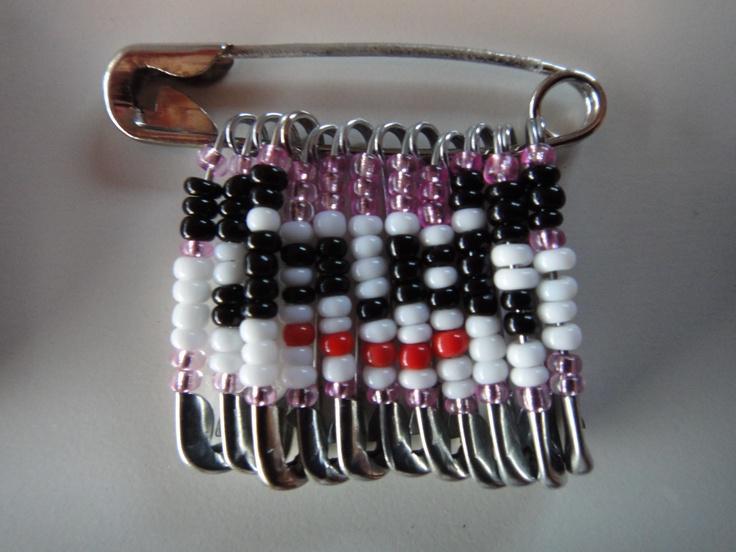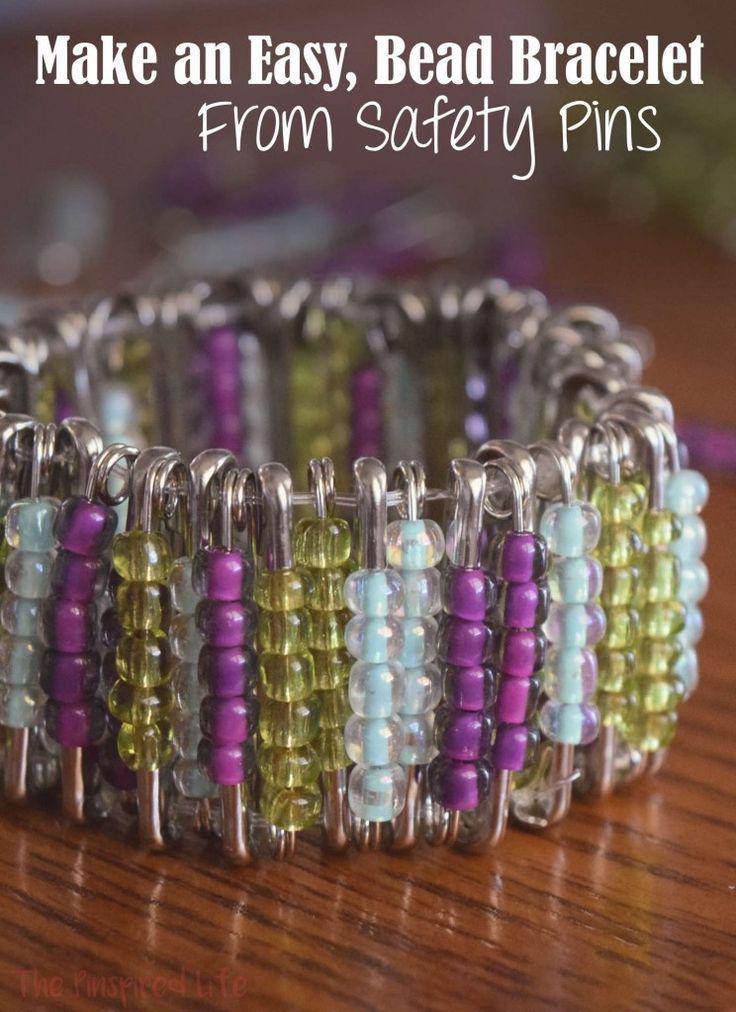The first image is the image on the left, the second image is the image on the right. Considering the images on both sides, is "One image shows a safety pin bracelet displayed on a flat surface, and the other image shows a safety pin strung with colored beads that form an animal image." valid? Answer yes or no. Yes. The first image is the image on the left, the second image is the image on the right. Evaluate the accuracy of this statement regarding the images: "the beads hanging from the safety pin to the left are mostly purple and blue". Is it true? Answer yes or no. No. 